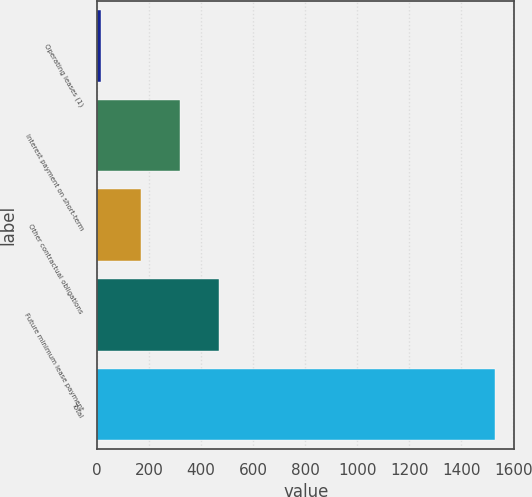<chart> <loc_0><loc_0><loc_500><loc_500><bar_chart><fcel>Operating leases (1)<fcel>Interest payment on short-term<fcel>Other contractual obligations<fcel>Future minimum lease payment<fcel>Total<nl><fcel>15.7<fcel>318.22<fcel>166.96<fcel>469.48<fcel>1528.3<nl></chart> 